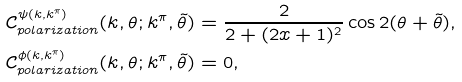Convert formula to latex. <formula><loc_0><loc_0><loc_500><loc_500>\mathcal { C } ^ { \psi ( k , k ^ { \pi } ) } _ { p o l a r i z a t i o n } ( k , \theta ; k ^ { \pi } , \tilde { \theta } ) & = \frac { 2 } { 2 + ( 2 x + 1 ) ^ { 2 } } \cos { 2 ( \theta + \tilde { \theta } ) } , \\ \mathcal { C } ^ { \phi ( k , k ^ { \pi } ) } _ { p o l a r i z a t i o n } ( k , \theta ; k ^ { \pi } , \tilde { \theta } ) & = 0 ,</formula> 